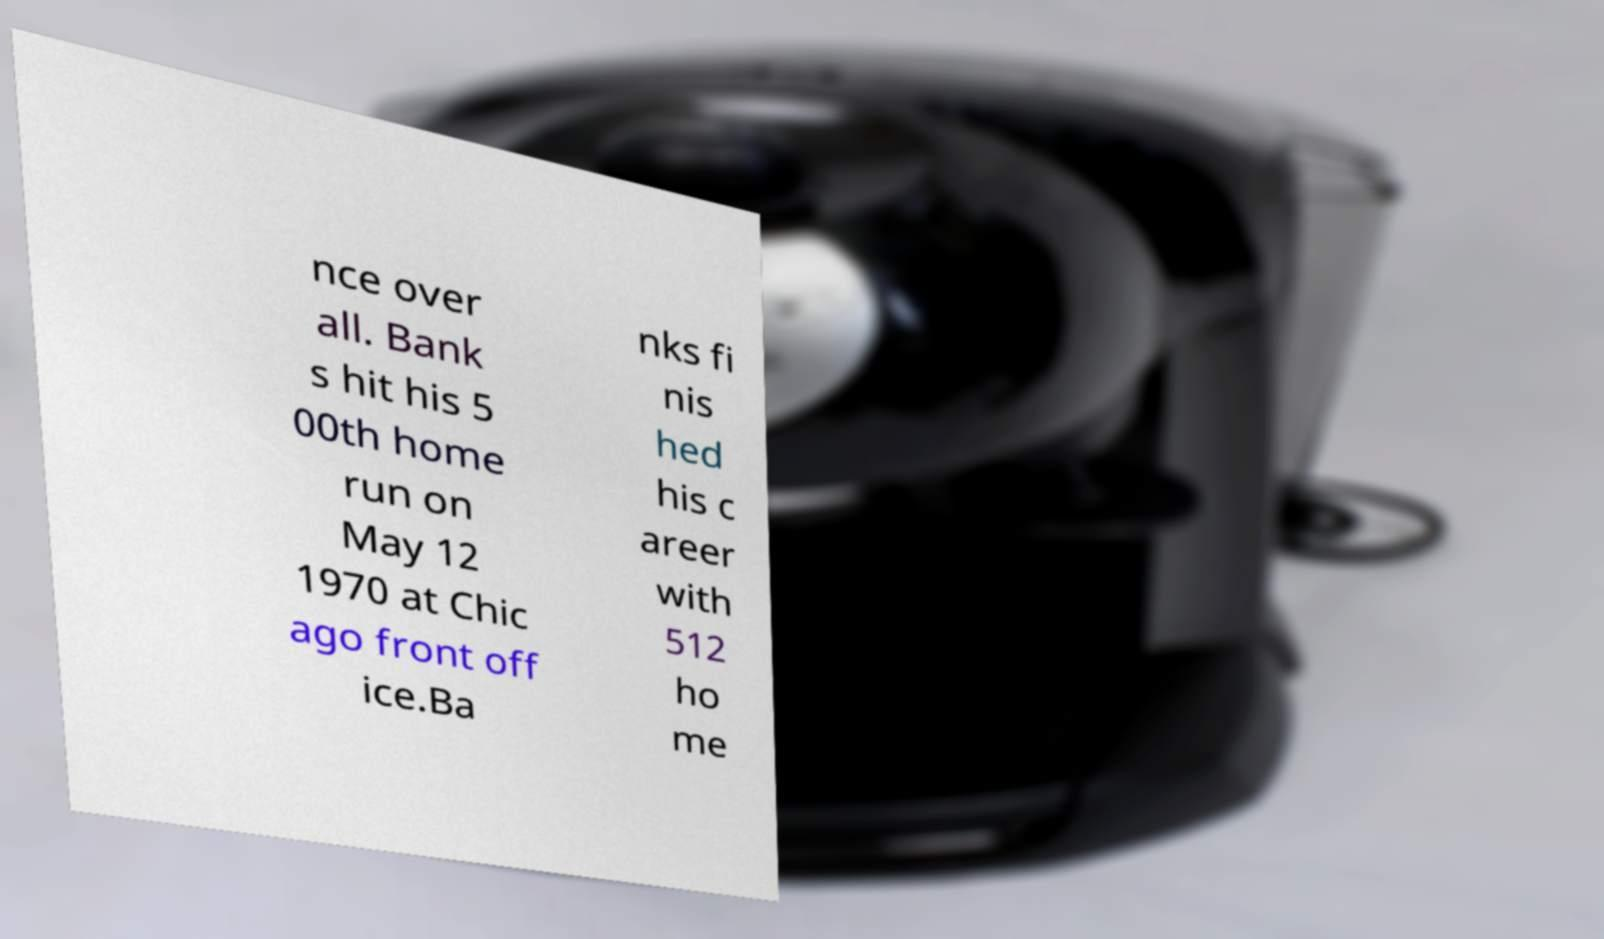What messages or text are displayed in this image? I need them in a readable, typed format. nce over all. Bank s hit his 5 00th home run on May 12 1970 at Chic ago front off ice.Ba nks fi nis hed his c areer with 512 ho me 